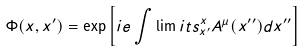<formula> <loc_0><loc_0><loc_500><loc_500>\Phi ( x , x ^ { \prime } ) = \exp \left [ i e \int \lim i t s ^ { x } _ { x ^ { \prime } } A ^ { \mu } ( x ^ { \prime \prime } ) d x ^ { \prime \prime } \right ]</formula> 